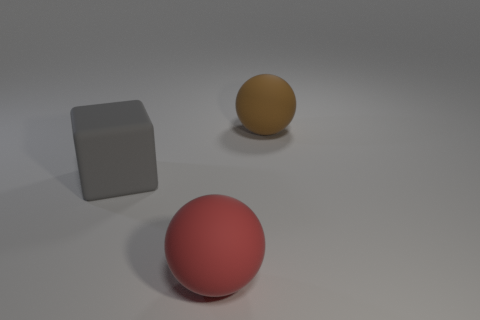Subtract all spheres. How many objects are left? 1 Add 1 large gray metallic blocks. How many objects exist? 4 Subtract all cyan cubes. Subtract all purple spheres. How many cubes are left? 1 Subtract all rubber cubes. Subtract all large rubber blocks. How many objects are left? 1 Add 3 large blocks. How many large blocks are left? 4 Add 1 large purple rubber things. How many large purple rubber things exist? 1 Subtract 0 purple spheres. How many objects are left? 3 